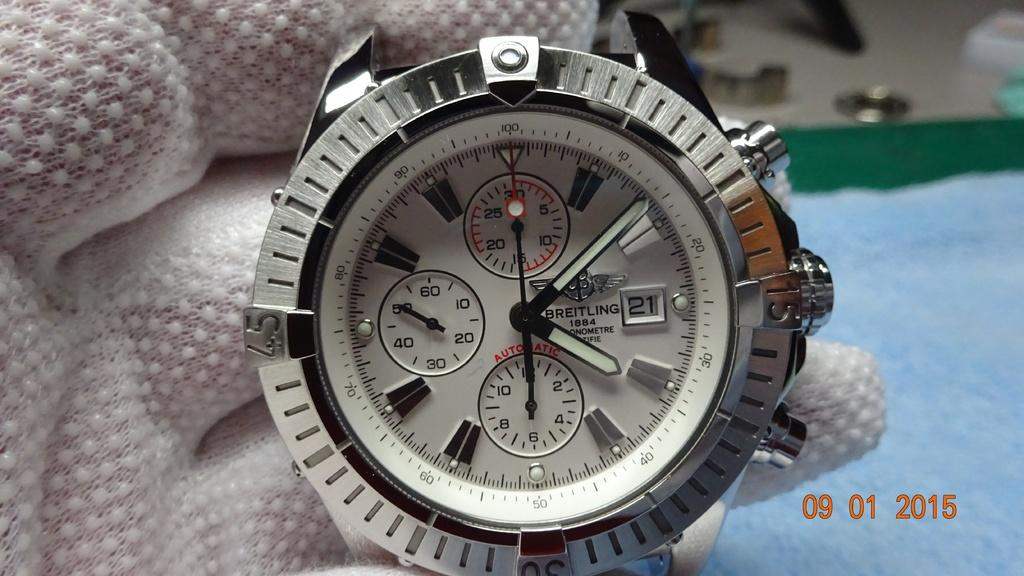Provide a one-sentence caption for the provided image. White and silver watch which has the word BREITLING on the face. 